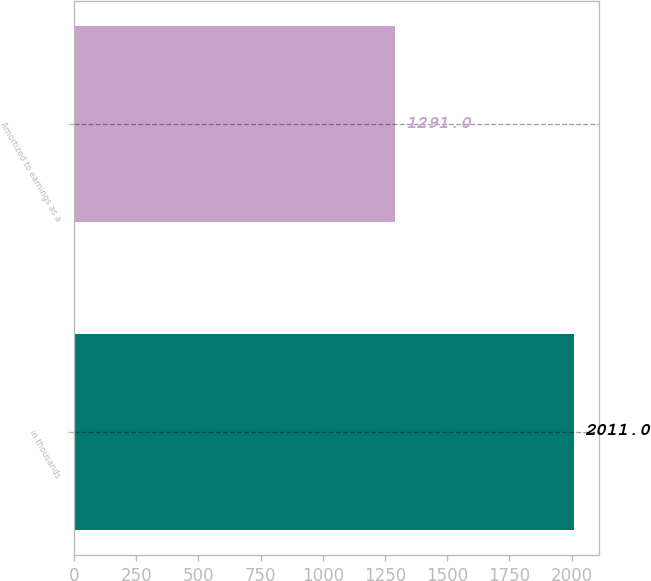Convert chart. <chart><loc_0><loc_0><loc_500><loc_500><bar_chart><fcel>in thousands<fcel>Amortized to earnings as a<nl><fcel>2011<fcel>1291<nl></chart> 